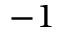<formula> <loc_0><loc_0><loc_500><loc_500>- 1</formula> 